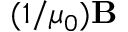<formula> <loc_0><loc_0><loc_500><loc_500>( 1 / \mu _ { 0 } ) B</formula> 